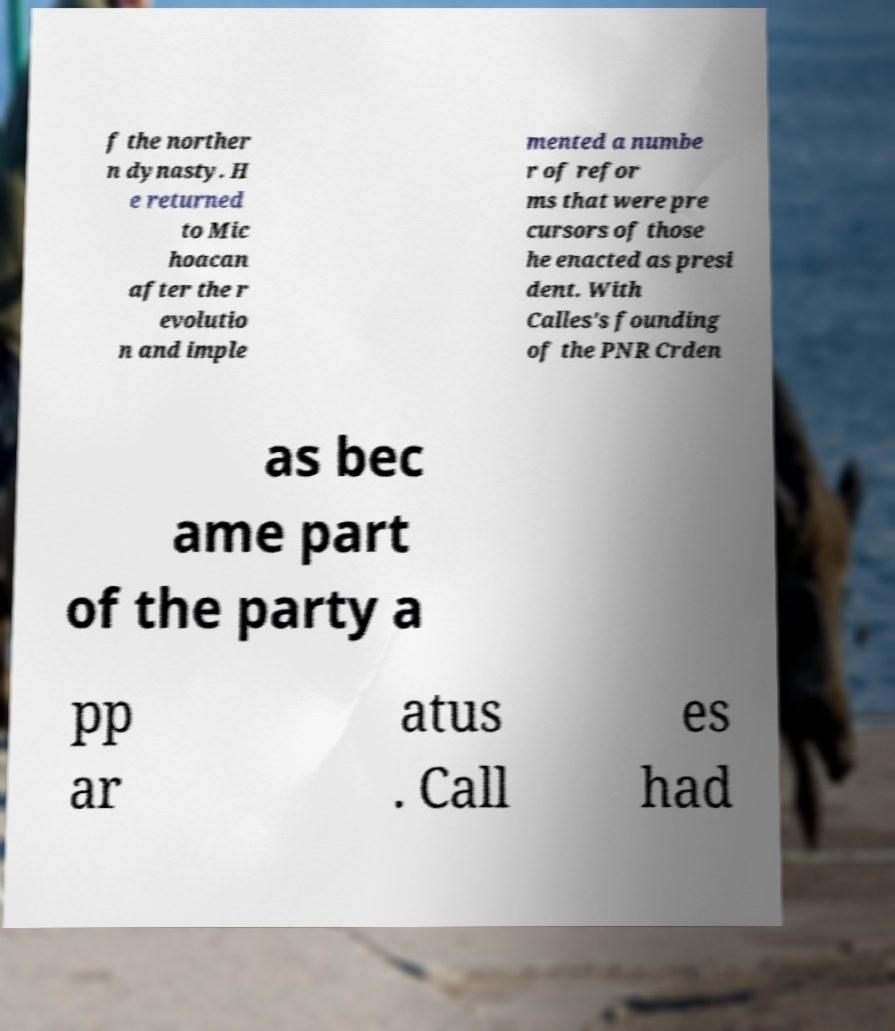For documentation purposes, I need the text within this image transcribed. Could you provide that? f the norther n dynasty. H e returned to Mic hoacan after the r evolutio n and imple mented a numbe r of refor ms that were pre cursors of those he enacted as presi dent. With Calles's founding of the PNR Crden as bec ame part of the party a pp ar atus . Call es had 